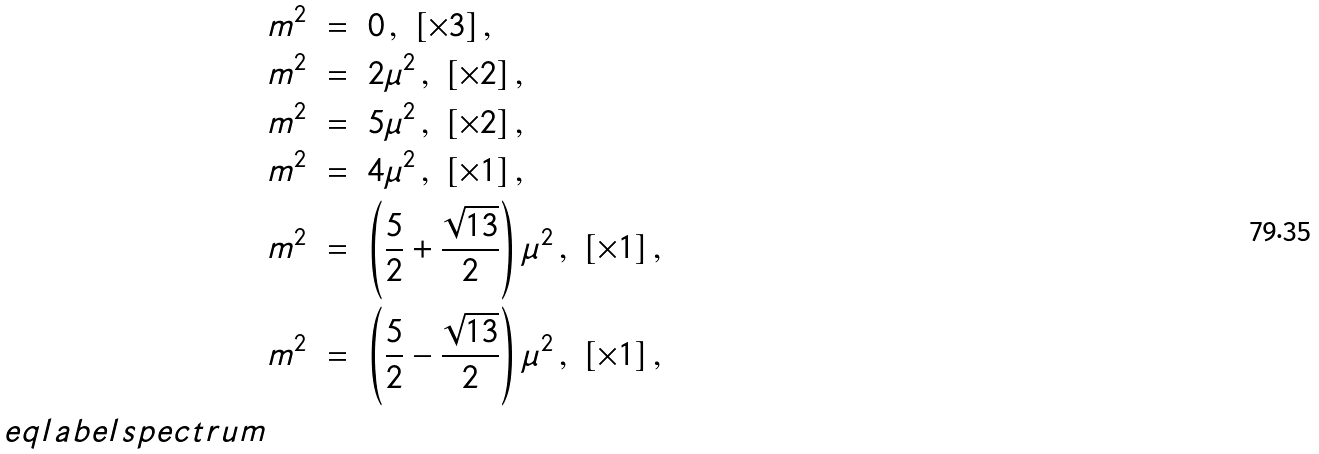<formula> <loc_0><loc_0><loc_500><loc_500>& m ^ { 2 } \ = \ 0 \, , \ [ \times 3 ] \, , \\ & m ^ { 2 } \ = \ 2 \mu ^ { 2 } \, , \ [ \times 2 ] \, , \\ & m ^ { 2 } \ = \ 5 \mu ^ { 2 } \, , \ [ \times 2 ] \, , \\ & m ^ { 2 } \ = \ 4 \mu ^ { 2 } \, , \ [ \times 1 ] \, , \\ & m ^ { 2 } \ = \ \left ( \frac { 5 } { 2 } + \frac { \sqrt { 1 3 } } { 2 } \right ) \mu ^ { 2 } \, , \ [ \times 1 ] \, , \\ & m ^ { 2 } \ = \ \left ( \frac { 5 } { 2 } - \frac { \sqrt { 1 3 } } { 2 } \right ) \mu ^ { 2 } \, , \ [ \times 1 ] \, , \\ \ e q l a b e l { s p e c t r u m }</formula> 